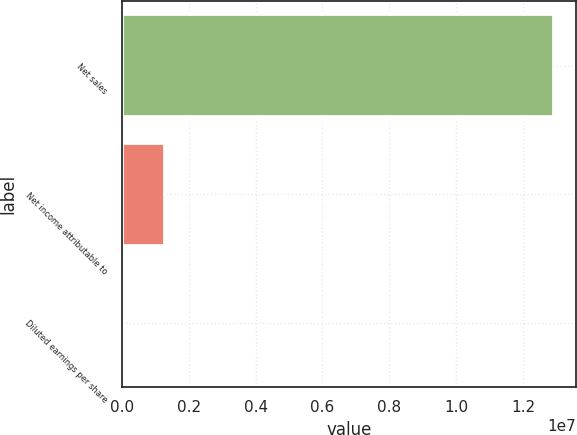Convert chart to OTSL. <chart><loc_0><loc_0><loc_500><loc_500><bar_chart><fcel>Net sales<fcel>Net income attributable to<fcel>Diluted earnings per share<nl><fcel>1.29358e+07<fcel>1.29359e+06<fcel>7.58<nl></chart> 